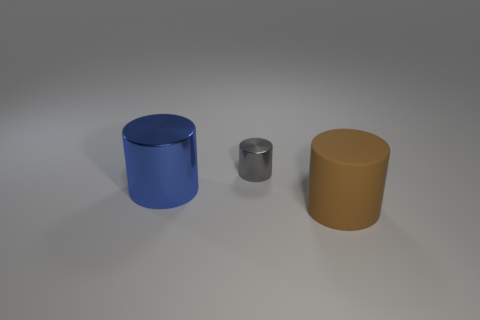Subtract all red cylinders. Subtract all red blocks. How many cylinders are left? 3 Add 2 rubber things. How many objects exist? 5 Subtract 0 purple spheres. How many objects are left? 3 Subtract all matte cylinders. Subtract all big rubber cylinders. How many objects are left? 1 Add 2 brown cylinders. How many brown cylinders are left? 3 Add 3 brown cylinders. How many brown cylinders exist? 4 